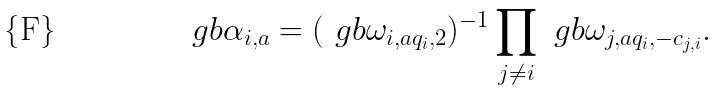Convert formula to latex. <formula><loc_0><loc_0><loc_500><loc_500>\ g b \alpha _ { i , a } = ( \ g b \omega _ { i , a q _ { i } , 2 } ) ^ { - 1 } \prod _ { j \ne i } \ g b \omega _ { j , a q _ { i } , - c _ { j , i } } .</formula> 